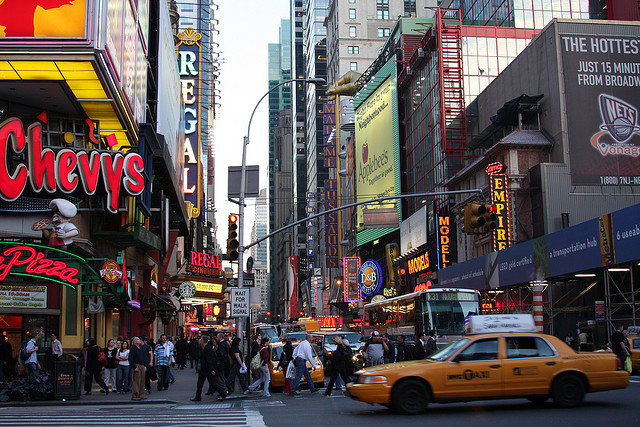What types of transportation are visible in the image, and how do they contribute to the overall urban environment? The image shows both pedestrians and motor vehicles, including yellow taxis, which are iconic to New York City's streets. The presence of these taxis not only highlights the city's reliance on diverse modes of transportation but also adds to the hectic and fast-paced nature of urban life observed in the scene. 